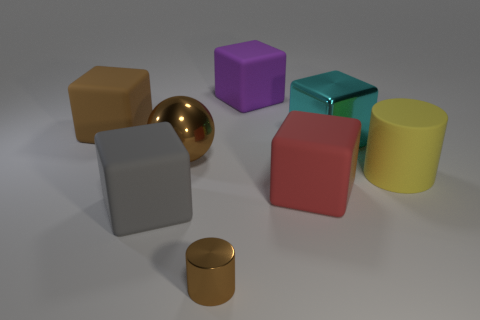Subtract all purple blocks. How many blocks are left? 4 Subtract all big purple cubes. How many cubes are left? 4 Subtract all green blocks. Subtract all green spheres. How many blocks are left? 5 Add 1 large yellow blocks. How many objects exist? 9 Subtract all cylinders. How many objects are left? 6 Subtract all large brown things. Subtract all cylinders. How many objects are left? 4 Add 5 large yellow matte objects. How many large yellow matte objects are left? 6 Add 4 red rubber blocks. How many red rubber blocks exist? 5 Subtract 0 blue cylinders. How many objects are left? 8 